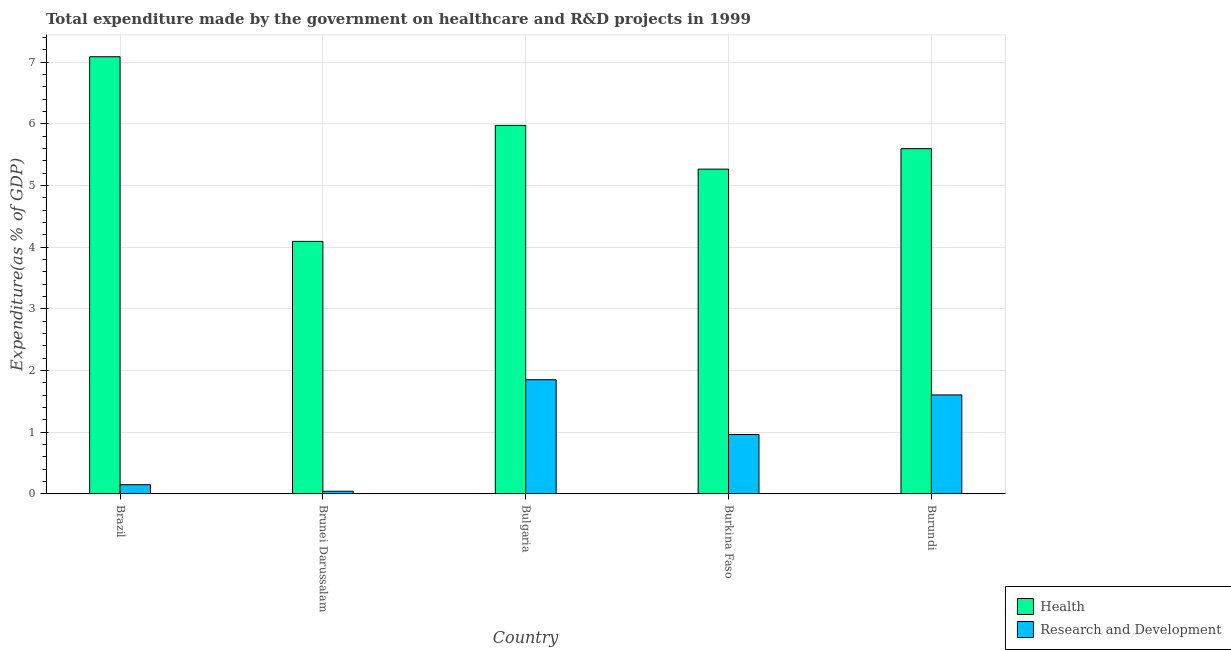How many different coloured bars are there?
Provide a short and direct response. 2. How many groups of bars are there?
Provide a succinct answer. 5. Are the number of bars per tick equal to the number of legend labels?
Your answer should be compact. Yes. Are the number of bars on each tick of the X-axis equal?
Provide a short and direct response. Yes. How many bars are there on the 5th tick from the right?
Provide a short and direct response. 2. What is the label of the 5th group of bars from the left?
Provide a short and direct response. Burundi. In how many cases, is the number of bars for a given country not equal to the number of legend labels?
Ensure brevity in your answer.  0. What is the expenditure in r&d in Brazil?
Ensure brevity in your answer.  0.15. Across all countries, what is the maximum expenditure in healthcare?
Offer a very short reply. 7.09. Across all countries, what is the minimum expenditure in healthcare?
Your answer should be very brief. 4.09. In which country was the expenditure in r&d minimum?
Your response must be concise. Brunei Darussalam. What is the total expenditure in healthcare in the graph?
Make the answer very short. 28.02. What is the difference between the expenditure in r&d in Brunei Darussalam and that in Burundi?
Provide a short and direct response. -1.56. What is the difference between the expenditure in healthcare in Brunei Darussalam and the expenditure in r&d in Bulgaria?
Offer a terse response. 2.24. What is the average expenditure in healthcare per country?
Offer a terse response. 5.6. What is the difference between the expenditure in r&d and expenditure in healthcare in Bulgaria?
Offer a very short reply. -4.12. What is the ratio of the expenditure in healthcare in Bulgaria to that in Burundi?
Ensure brevity in your answer.  1.07. What is the difference between the highest and the second highest expenditure in r&d?
Offer a very short reply. 0.25. What is the difference between the highest and the lowest expenditure in r&d?
Keep it short and to the point. 1.81. What does the 1st bar from the left in Brunei Darussalam represents?
Make the answer very short. Health. What does the 2nd bar from the right in Bulgaria represents?
Keep it short and to the point. Health. Are all the bars in the graph horizontal?
Your answer should be compact. No. What is the difference between two consecutive major ticks on the Y-axis?
Your response must be concise. 1. Does the graph contain any zero values?
Give a very brief answer. No. How many legend labels are there?
Provide a short and direct response. 2. How are the legend labels stacked?
Your response must be concise. Vertical. What is the title of the graph?
Your answer should be very brief. Total expenditure made by the government on healthcare and R&D projects in 1999. What is the label or title of the X-axis?
Your answer should be compact. Country. What is the label or title of the Y-axis?
Your answer should be very brief. Expenditure(as % of GDP). What is the Expenditure(as % of GDP) of Health in Brazil?
Make the answer very short. 7.09. What is the Expenditure(as % of GDP) of Research and Development in Brazil?
Give a very brief answer. 0.15. What is the Expenditure(as % of GDP) in Health in Brunei Darussalam?
Offer a very short reply. 4.09. What is the Expenditure(as % of GDP) in Research and Development in Brunei Darussalam?
Your answer should be compact. 0.04. What is the Expenditure(as % of GDP) of Health in Bulgaria?
Offer a very short reply. 5.97. What is the Expenditure(as % of GDP) in Research and Development in Bulgaria?
Provide a short and direct response. 1.85. What is the Expenditure(as % of GDP) in Health in Burkina Faso?
Give a very brief answer. 5.26. What is the Expenditure(as % of GDP) in Research and Development in Burkina Faso?
Your answer should be compact. 0.96. What is the Expenditure(as % of GDP) in Health in Burundi?
Provide a succinct answer. 5.6. What is the Expenditure(as % of GDP) in Research and Development in Burundi?
Keep it short and to the point. 1.61. Across all countries, what is the maximum Expenditure(as % of GDP) in Health?
Offer a very short reply. 7.09. Across all countries, what is the maximum Expenditure(as % of GDP) in Research and Development?
Ensure brevity in your answer.  1.85. Across all countries, what is the minimum Expenditure(as % of GDP) of Health?
Your answer should be very brief. 4.09. Across all countries, what is the minimum Expenditure(as % of GDP) of Research and Development?
Offer a terse response. 0.04. What is the total Expenditure(as % of GDP) in Health in the graph?
Provide a succinct answer. 28.02. What is the total Expenditure(as % of GDP) of Research and Development in the graph?
Your answer should be very brief. 4.62. What is the difference between the Expenditure(as % of GDP) of Health in Brazil and that in Brunei Darussalam?
Give a very brief answer. 2.99. What is the difference between the Expenditure(as % of GDP) in Research and Development in Brazil and that in Brunei Darussalam?
Provide a succinct answer. 0.11. What is the difference between the Expenditure(as % of GDP) in Health in Brazil and that in Bulgaria?
Provide a short and direct response. 1.11. What is the difference between the Expenditure(as % of GDP) of Research and Development in Brazil and that in Bulgaria?
Provide a short and direct response. -1.7. What is the difference between the Expenditure(as % of GDP) in Health in Brazil and that in Burkina Faso?
Make the answer very short. 1.82. What is the difference between the Expenditure(as % of GDP) of Research and Development in Brazil and that in Burkina Faso?
Provide a succinct answer. -0.81. What is the difference between the Expenditure(as % of GDP) in Health in Brazil and that in Burundi?
Your answer should be compact. 1.49. What is the difference between the Expenditure(as % of GDP) in Research and Development in Brazil and that in Burundi?
Keep it short and to the point. -1.46. What is the difference between the Expenditure(as % of GDP) of Health in Brunei Darussalam and that in Bulgaria?
Your answer should be very brief. -1.88. What is the difference between the Expenditure(as % of GDP) in Research and Development in Brunei Darussalam and that in Bulgaria?
Your answer should be compact. -1.81. What is the difference between the Expenditure(as % of GDP) of Health in Brunei Darussalam and that in Burkina Faso?
Give a very brief answer. -1.17. What is the difference between the Expenditure(as % of GDP) in Research and Development in Brunei Darussalam and that in Burkina Faso?
Give a very brief answer. -0.92. What is the difference between the Expenditure(as % of GDP) in Health in Brunei Darussalam and that in Burundi?
Keep it short and to the point. -1.5. What is the difference between the Expenditure(as % of GDP) of Research and Development in Brunei Darussalam and that in Burundi?
Offer a terse response. -1.56. What is the difference between the Expenditure(as % of GDP) of Health in Bulgaria and that in Burkina Faso?
Provide a succinct answer. 0.71. What is the difference between the Expenditure(as % of GDP) in Research and Development in Bulgaria and that in Burkina Faso?
Your answer should be very brief. 0.89. What is the difference between the Expenditure(as % of GDP) in Health in Bulgaria and that in Burundi?
Keep it short and to the point. 0.38. What is the difference between the Expenditure(as % of GDP) of Research and Development in Bulgaria and that in Burundi?
Make the answer very short. 0.25. What is the difference between the Expenditure(as % of GDP) of Health in Burkina Faso and that in Burundi?
Offer a terse response. -0.33. What is the difference between the Expenditure(as % of GDP) of Research and Development in Burkina Faso and that in Burundi?
Offer a very short reply. -0.64. What is the difference between the Expenditure(as % of GDP) in Health in Brazil and the Expenditure(as % of GDP) in Research and Development in Brunei Darussalam?
Your response must be concise. 7.04. What is the difference between the Expenditure(as % of GDP) of Health in Brazil and the Expenditure(as % of GDP) of Research and Development in Bulgaria?
Ensure brevity in your answer.  5.24. What is the difference between the Expenditure(as % of GDP) of Health in Brazil and the Expenditure(as % of GDP) of Research and Development in Burkina Faso?
Offer a very short reply. 6.12. What is the difference between the Expenditure(as % of GDP) in Health in Brazil and the Expenditure(as % of GDP) in Research and Development in Burundi?
Offer a terse response. 5.48. What is the difference between the Expenditure(as % of GDP) in Health in Brunei Darussalam and the Expenditure(as % of GDP) in Research and Development in Bulgaria?
Provide a succinct answer. 2.24. What is the difference between the Expenditure(as % of GDP) in Health in Brunei Darussalam and the Expenditure(as % of GDP) in Research and Development in Burkina Faso?
Offer a very short reply. 3.13. What is the difference between the Expenditure(as % of GDP) in Health in Brunei Darussalam and the Expenditure(as % of GDP) in Research and Development in Burundi?
Ensure brevity in your answer.  2.49. What is the difference between the Expenditure(as % of GDP) in Health in Bulgaria and the Expenditure(as % of GDP) in Research and Development in Burkina Faso?
Ensure brevity in your answer.  5.01. What is the difference between the Expenditure(as % of GDP) in Health in Bulgaria and the Expenditure(as % of GDP) in Research and Development in Burundi?
Your response must be concise. 4.37. What is the difference between the Expenditure(as % of GDP) in Health in Burkina Faso and the Expenditure(as % of GDP) in Research and Development in Burundi?
Offer a terse response. 3.66. What is the average Expenditure(as % of GDP) of Health per country?
Make the answer very short. 5.6. What is the average Expenditure(as % of GDP) in Research and Development per country?
Your answer should be compact. 0.92. What is the difference between the Expenditure(as % of GDP) in Health and Expenditure(as % of GDP) in Research and Development in Brazil?
Offer a terse response. 6.94. What is the difference between the Expenditure(as % of GDP) in Health and Expenditure(as % of GDP) in Research and Development in Brunei Darussalam?
Offer a terse response. 4.05. What is the difference between the Expenditure(as % of GDP) of Health and Expenditure(as % of GDP) of Research and Development in Bulgaria?
Offer a very short reply. 4.12. What is the difference between the Expenditure(as % of GDP) in Health and Expenditure(as % of GDP) in Research and Development in Burkina Faso?
Provide a succinct answer. 4.3. What is the difference between the Expenditure(as % of GDP) of Health and Expenditure(as % of GDP) of Research and Development in Burundi?
Offer a very short reply. 3.99. What is the ratio of the Expenditure(as % of GDP) in Health in Brazil to that in Brunei Darussalam?
Keep it short and to the point. 1.73. What is the ratio of the Expenditure(as % of GDP) in Research and Development in Brazil to that in Brunei Darussalam?
Your answer should be very brief. 3.41. What is the ratio of the Expenditure(as % of GDP) of Health in Brazil to that in Bulgaria?
Keep it short and to the point. 1.19. What is the ratio of the Expenditure(as % of GDP) in Research and Development in Brazil to that in Bulgaria?
Provide a succinct answer. 0.08. What is the ratio of the Expenditure(as % of GDP) in Health in Brazil to that in Burkina Faso?
Offer a very short reply. 1.35. What is the ratio of the Expenditure(as % of GDP) of Research and Development in Brazil to that in Burkina Faso?
Make the answer very short. 0.16. What is the ratio of the Expenditure(as % of GDP) of Health in Brazil to that in Burundi?
Your answer should be compact. 1.27. What is the ratio of the Expenditure(as % of GDP) of Research and Development in Brazil to that in Burundi?
Your response must be concise. 0.09. What is the ratio of the Expenditure(as % of GDP) in Health in Brunei Darussalam to that in Bulgaria?
Provide a short and direct response. 0.69. What is the ratio of the Expenditure(as % of GDP) of Research and Development in Brunei Darussalam to that in Bulgaria?
Make the answer very short. 0.02. What is the ratio of the Expenditure(as % of GDP) in Health in Brunei Darussalam to that in Burkina Faso?
Offer a terse response. 0.78. What is the ratio of the Expenditure(as % of GDP) in Research and Development in Brunei Darussalam to that in Burkina Faso?
Make the answer very short. 0.05. What is the ratio of the Expenditure(as % of GDP) of Health in Brunei Darussalam to that in Burundi?
Keep it short and to the point. 0.73. What is the ratio of the Expenditure(as % of GDP) in Research and Development in Brunei Darussalam to that in Burundi?
Make the answer very short. 0.03. What is the ratio of the Expenditure(as % of GDP) of Health in Bulgaria to that in Burkina Faso?
Your answer should be very brief. 1.13. What is the ratio of the Expenditure(as % of GDP) of Research and Development in Bulgaria to that in Burkina Faso?
Keep it short and to the point. 1.92. What is the ratio of the Expenditure(as % of GDP) in Health in Bulgaria to that in Burundi?
Ensure brevity in your answer.  1.07. What is the ratio of the Expenditure(as % of GDP) in Research and Development in Bulgaria to that in Burundi?
Offer a very short reply. 1.15. What is the ratio of the Expenditure(as % of GDP) of Health in Burkina Faso to that in Burundi?
Make the answer very short. 0.94. What is the ratio of the Expenditure(as % of GDP) of Research and Development in Burkina Faso to that in Burundi?
Provide a succinct answer. 0.6. What is the difference between the highest and the second highest Expenditure(as % of GDP) in Health?
Offer a terse response. 1.11. What is the difference between the highest and the second highest Expenditure(as % of GDP) of Research and Development?
Your answer should be compact. 0.25. What is the difference between the highest and the lowest Expenditure(as % of GDP) in Health?
Provide a succinct answer. 2.99. What is the difference between the highest and the lowest Expenditure(as % of GDP) in Research and Development?
Give a very brief answer. 1.81. 